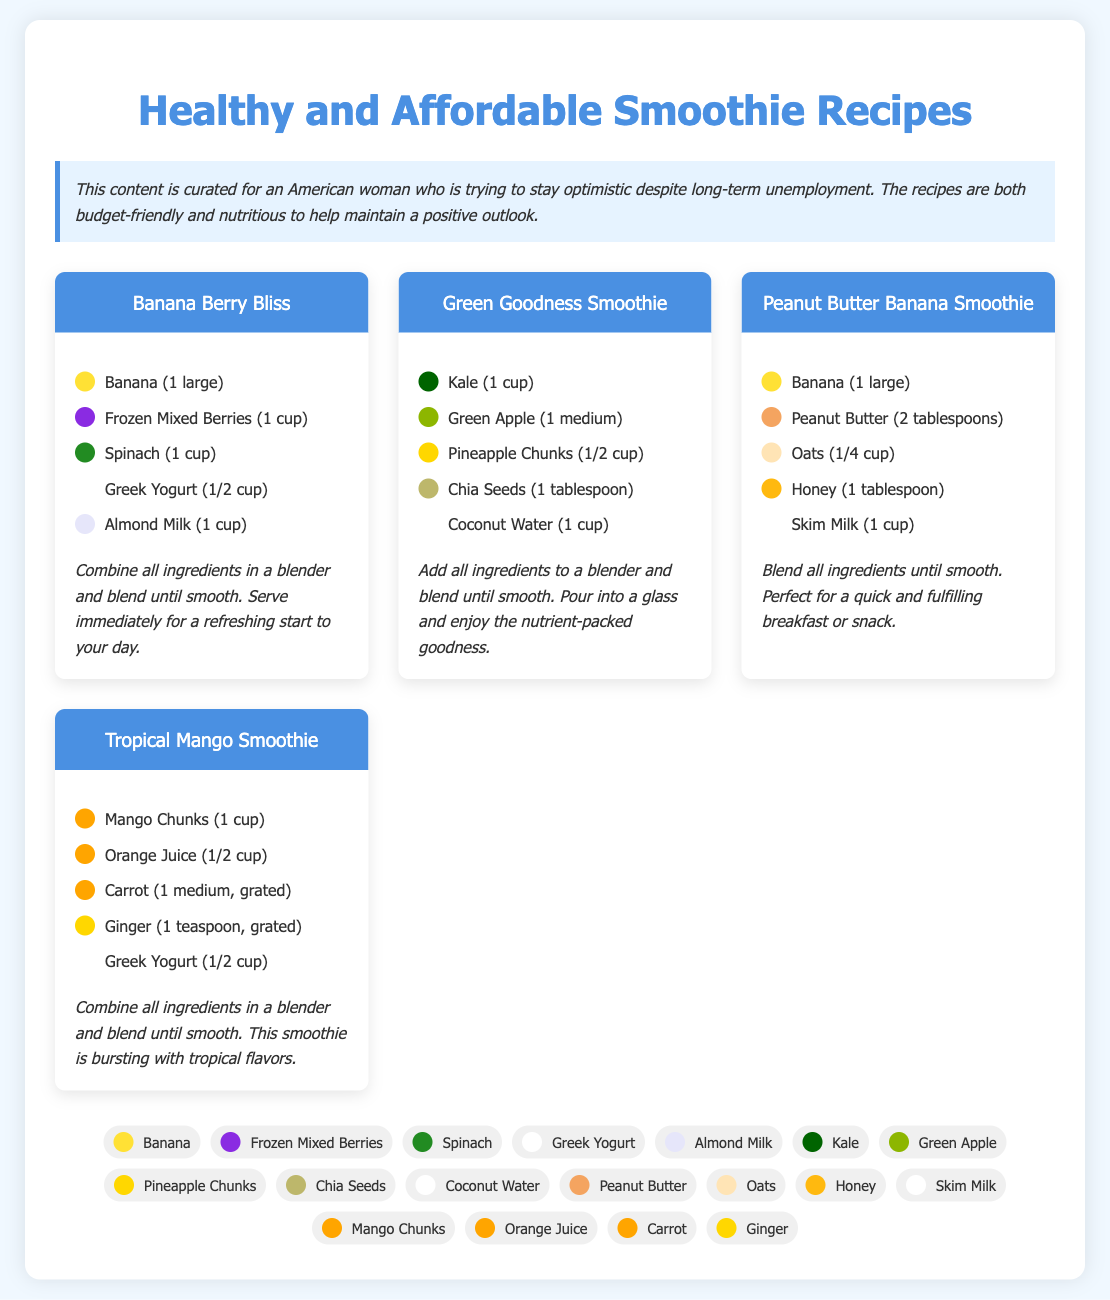What is the title of the document? The title of the document is prominently displayed at the top of the page.
Answer: Healthy and Affordable Smoothie Recipes How many recipes are included in the document? There are four distinct recipes listed in the recipe grid section.
Answer: Four What ingredient is common in all smoothie recipes? Each recipe includes bananas or their equivalent as one of the ingredients.
Answer: Banana What color represents almonds in the visual guide? The visual guide displays colors corresponding to each ingredient; the almond milk color is light.
Answer: White What is the main green ingredient in the "Green Goodness Smoothie"? The primary leafy green ingredient featured in this smoothie recipe is kale.
Answer: Kale How much honey is used in the Peanut Butter Banana Smoothie? The document lists the quantity of honey needed for the Peanut Butter Banana Smoothie specifically.
Answer: One tablespoon What is the blending instruction common to all recipes? The blending instruction is a shared final step mentioned in every recipe's preparation method.
Answer: Blend until smooth Which smoothie contains coconut water? The Green Goodness Smoothie is the only recipe that specifically lists coconut water as an ingredient.
Answer: Green Goodness Smoothie What type of yogurt is used in the Tropical Mango Smoothie? The ingredient listing specifies the type of yogurt included in this particular smoothie.
Answer: Greek Yogurt 